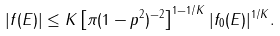Convert formula to latex. <formula><loc_0><loc_0><loc_500><loc_500>| f ( E ) | \leq K \left [ \pi ( 1 - p ^ { 2 } ) ^ { - 2 } \right ] ^ { 1 - 1 / K } | f _ { 0 } ( E ) | ^ { 1 / K } .</formula> 